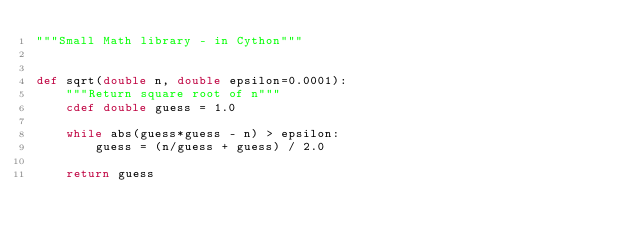<code> <loc_0><loc_0><loc_500><loc_500><_Cython_>"""Small Math library - in Cython"""


def sqrt(double n, double epsilon=0.0001):
    """Return square root of n"""
    cdef double guess = 1.0

    while abs(guess*guess - n) > epsilon:
        guess = (n/guess + guess) / 2.0

    return guess

</code> 